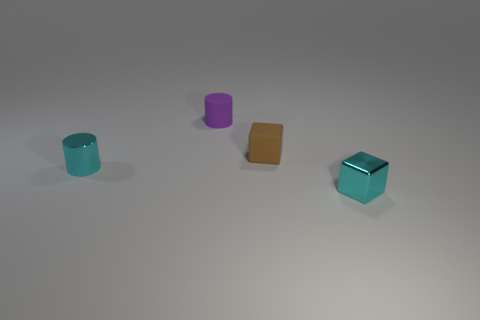What is the material of the cylinder right of the shiny object to the left of the small purple cylinder?
Offer a very short reply. Rubber. The small object that is in front of the shiny object left of the cylinder right of the small cyan metallic cylinder is what color?
Your answer should be very brief. Cyan. There is a brown object that is made of the same material as the tiny purple cylinder; what is its shape?
Your answer should be very brief. Cube. Are there fewer blue balls than shiny cylinders?
Make the answer very short. Yes. Are the brown cube and the purple cylinder made of the same material?
Make the answer very short. Yes. How many other objects are there of the same color as the tiny shiny cube?
Your answer should be compact. 1. Is the number of brown rubber objects greater than the number of metal objects?
Ensure brevity in your answer.  No. What color is the tiny cylinder in front of the small brown matte cube?
Make the answer very short. Cyan. How many cyan objects are either small cylinders or rubber things?
Give a very brief answer. 1. The matte block is what color?
Your answer should be very brief. Brown. 